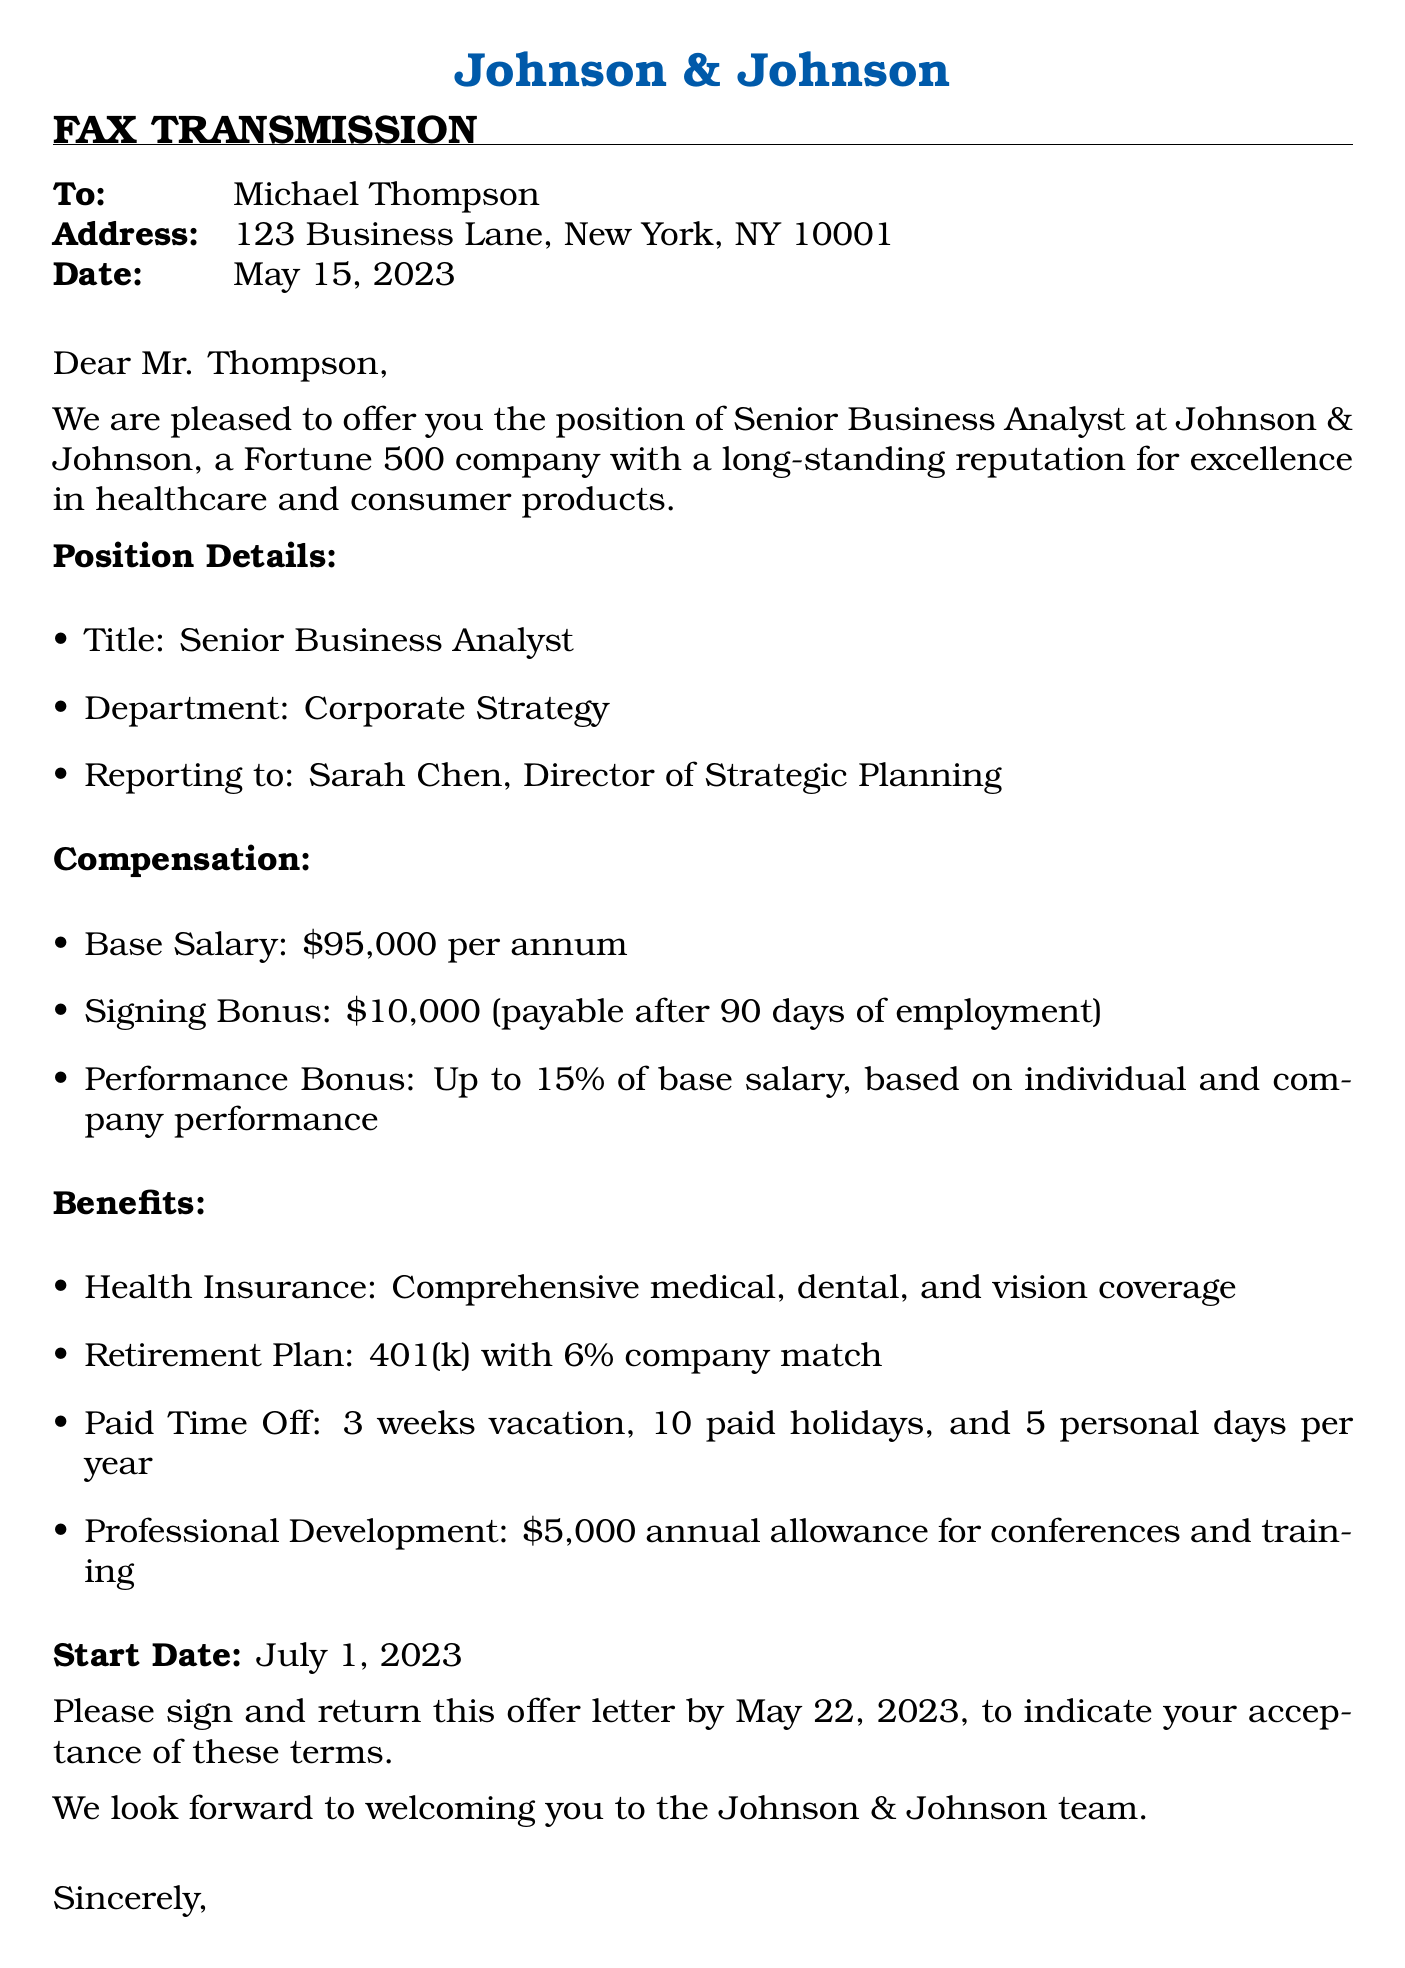what is the recipient's name? The recipient's name is mentioned in the document's address section.
Answer: Michael Thompson what is the job title being offered? The job title is stated early in the document under "Position Details."
Answer: Senior Business Analyst what is the base salary for the position? The base salary is specified in the "Compensation" section of the document.
Answer: $95,000 per annum what is the amount of the signing bonus? The signing bonus is provided in the "Compensation" section of the letter.
Answer: $10,000 how many weeks of vacation are offered? The number of vacation weeks is listed under the "Benefits" section.
Answer: 3 weeks what is the start date for the position? The start date is clearly stated towards the end of the document.
Answer: July 1, 2023 what percentage can the performance bonus reach? The performance bonus percentage is mentioned in the "Compensation" section.
Answer: Up to 15% who should the signed letter be returned to? The name of the person to whom the letter should be returned is mentioned in the salutation.
Answer: Emily Rodriguez what is the document type? The document type is evident from the heading at the beginning of the letter.
Answer: Fax transmission 